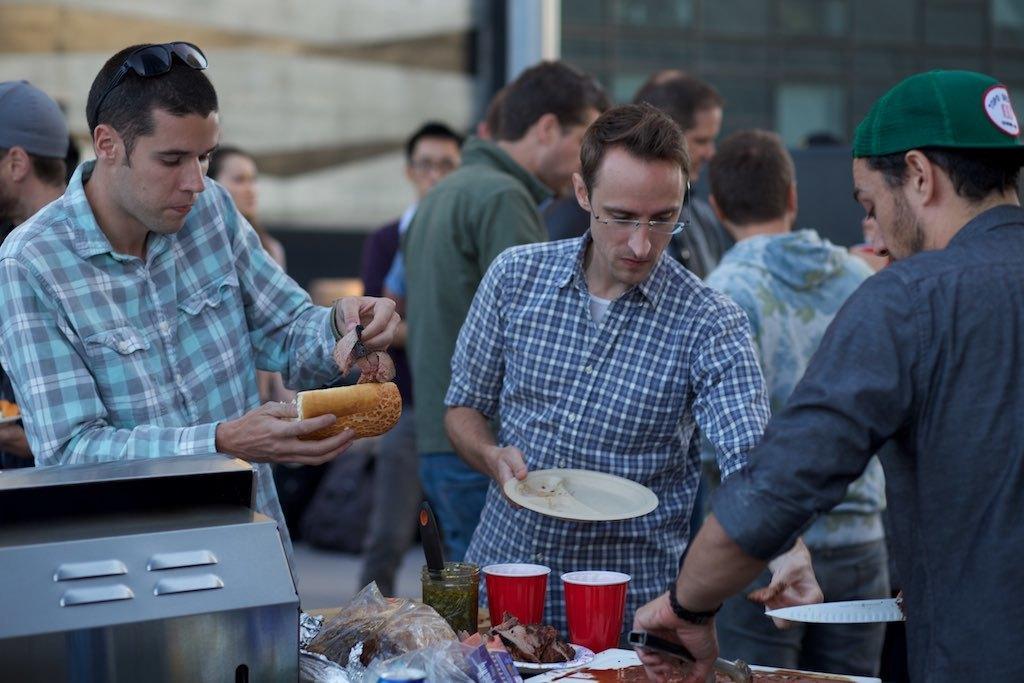Can you describe this image briefly? This image consists of so many persons in the middle. There are some eatables at the bottom. There are covers and glasses. There are some persons who are eating. 